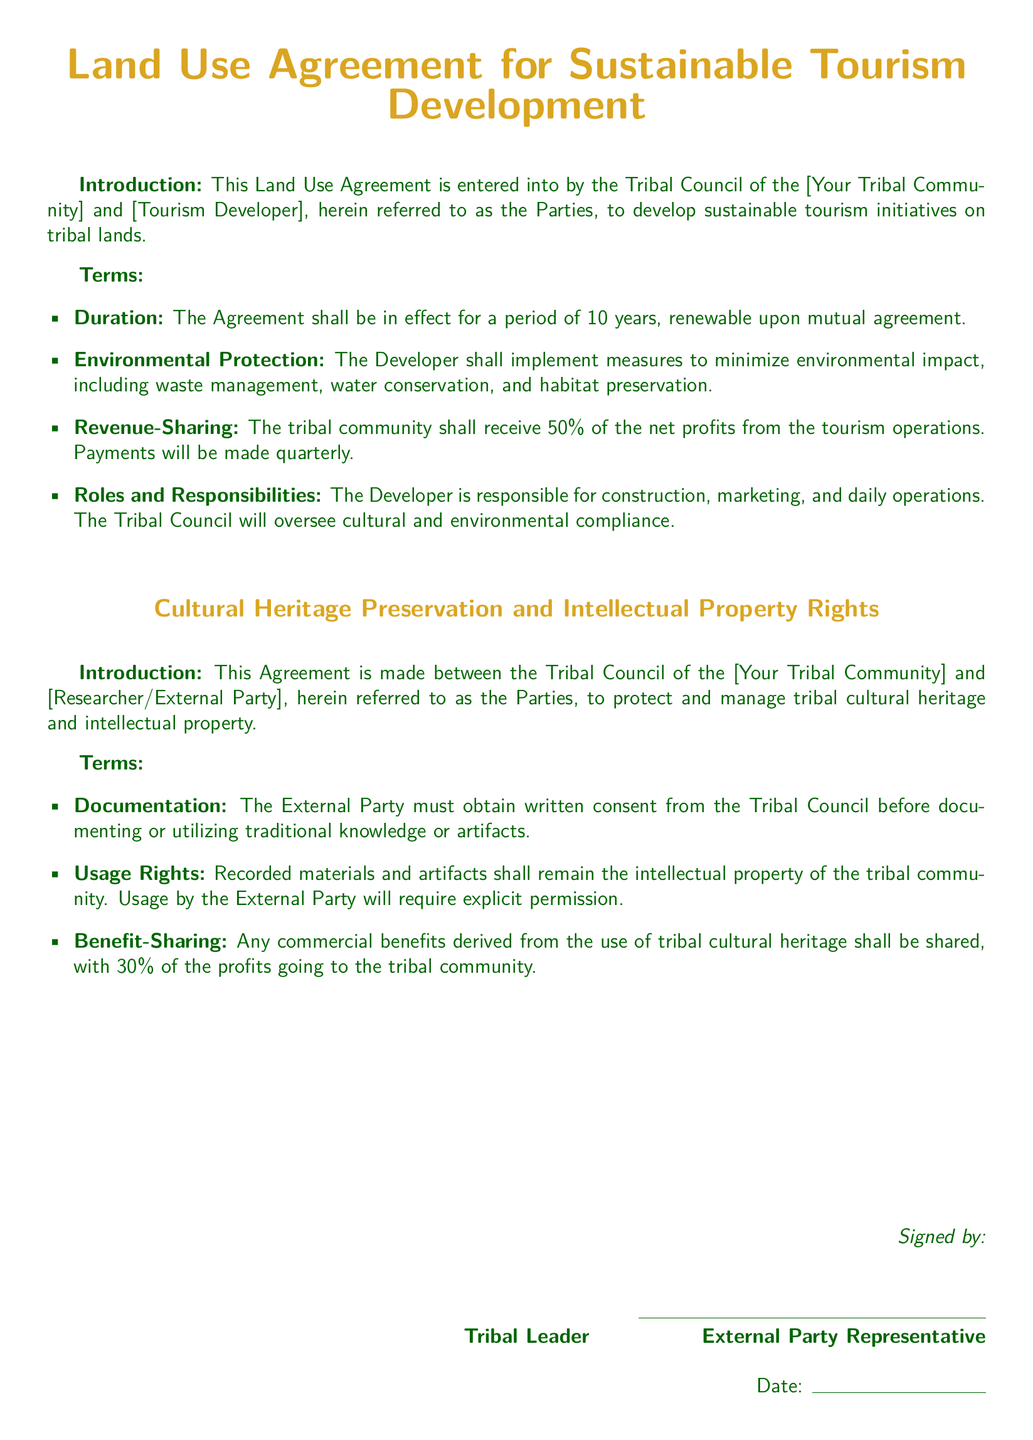What is the duration of the Land Use Agreement? The duration is specified in the terms of the Land Use Agreement, which states it shall be in effect for a period of 10 years.
Answer: 10 years What percentage of net profits will the tribal community receive? The revenue-sharing model in the agreement outlines that the tribal community will receive 50% of the net profits.
Answer: 50% Who is responsible for construction and marketing in the Land Use Agreement? The roles and responsibilities section identifies the Developer as responsible for construction and marketing.
Answer: Developer What must the External Party obtain before documenting traditional knowledge? The agreement specifies that the External Party must obtain written consent from the Tribal Council before documentation.
Answer: Written consent What is the profit share percentage for the tribal community from commercial benefits derived from cultural heritage? The benefit-sharing clause indicates that 30% of the profits from commercial benefits will go to the tribal community.
Answer: 30% What is the main focus of the Cultural Heritage Preservation Agreement? The main focus of the agreement is to protect and manage tribal cultural heritage and intellectual property rights.
Answer: Protection and management What is the primary responsibility of the Tribal Council in the Land Use Agreement? The agreement states that the Tribal Council will oversee cultural and environmental compliance, highlighting their primary responsibility.
Answer: Oversee compliance How often will payments be made to the tribal community from tourism operations? The revenue-sharing terms specify that payments will be made quarterly to the tribal community.
Answer: Quarterly What type of agreement is the Community Health Partnership Agreement focused on? The title indicates that it is focused on establishing a partnership with healthcare providers to enhance access and services.
Answer: Healthcare partnership 